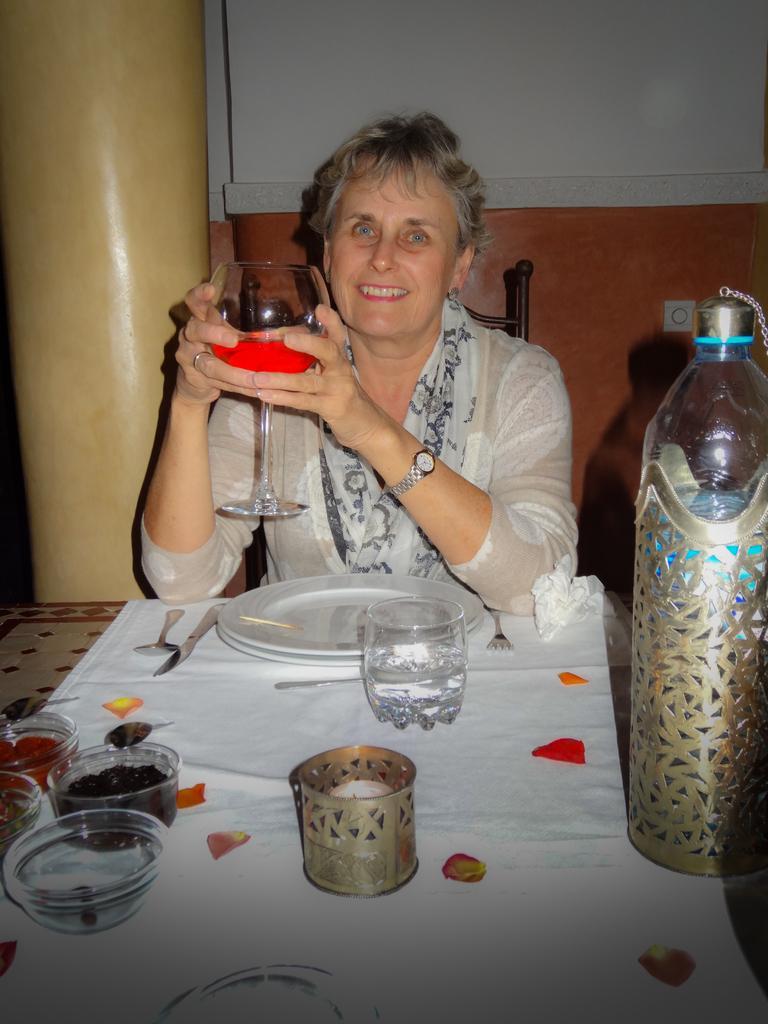In one or two sentences, can you explain what this image depicts? In this picture woman is sitting on the chair in the center and is holding a glass with a drink having a smile on her face. In front of the woman there is a plate, glass, bowls, white colour cloth on the table, spoon, and a knife on the left side. At the right side there is a folk, and a tissue paper. In the background there is a wall and, in the left there is a pillar. 